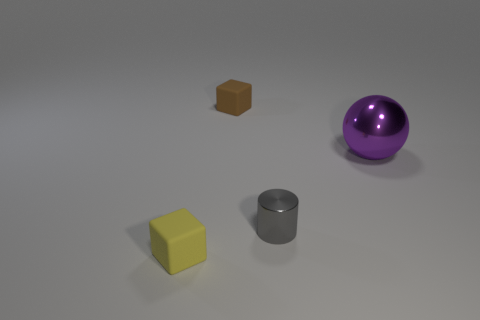Add 1 large yellow rubber cubes. How many objects exist? 5 Subtract all cylinders. How many objects are left? 3 Add 2 tiny cubes. How many tiny cubes are left? 4 Add 3 spheres. How many spheres exist? 4 Subtract 0 gray blocks. How many objects are left? 4 Subtract all gray metallic cylinders. Subtract all tiny matte cubes. How many objects are left? 1 